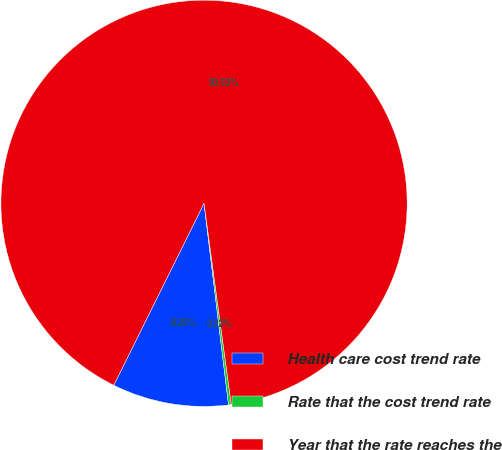Convert chart. <chart><loc_0><loc_0><loc_500><loc_500><pie_chart><fcel>Health care cost trend rate<fcel>Rate that the cost trend rate<fcel>Year that the rate reaches the<nl><fcel>9.25%<fcel>0.22%<fcel>90.52%<nl></chart> 